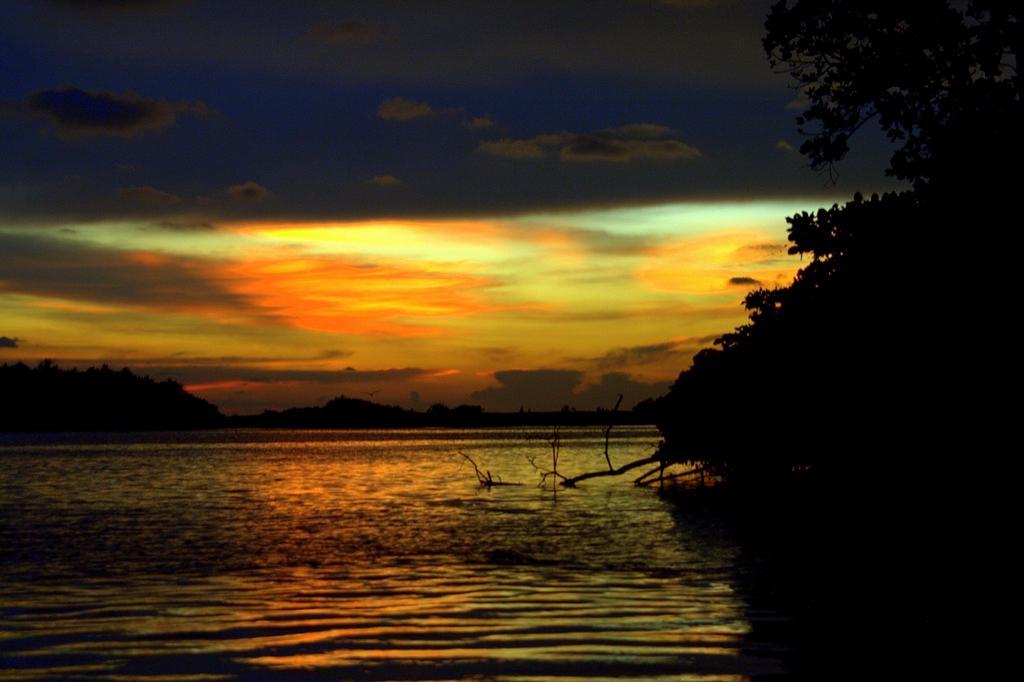Describe this image in one or two sentences. This image consists of water. To the right, there is a tree. At the top, there are clouds in the sky. 